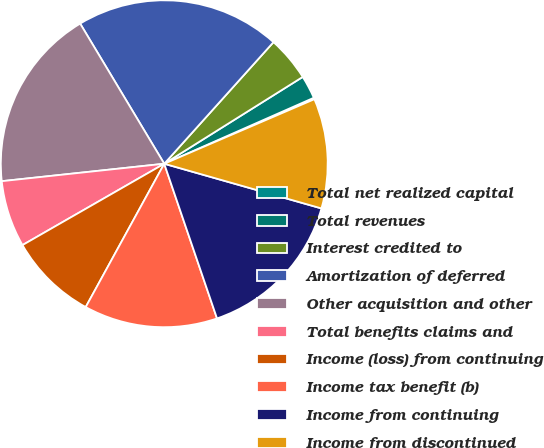Convert chart to OTSL. <chart><loc_0><loc_0><loc_500><loc_500><pie_chart><fcel>Total net realized capital<fcel>Total revenues<fcel>Interest credited to<fcel>Amortization of deferred<fcel>Other acquisition and other<fcel>Total benefits claims and<fcel>Income (loss) from continuing<fcel>Income tax benefit (b)<fcel>Income from continuing<fcel>Income from discontinued<nl><fcel>0.15%<fcel>2.3%<fcel>4.44%<fcel>20.25%<fcel>18.1%<fcel>6.59%<fcel>8.73%<fcel>13.21%<fcel>15.36%<fcel>10.87%<nl></chart> 